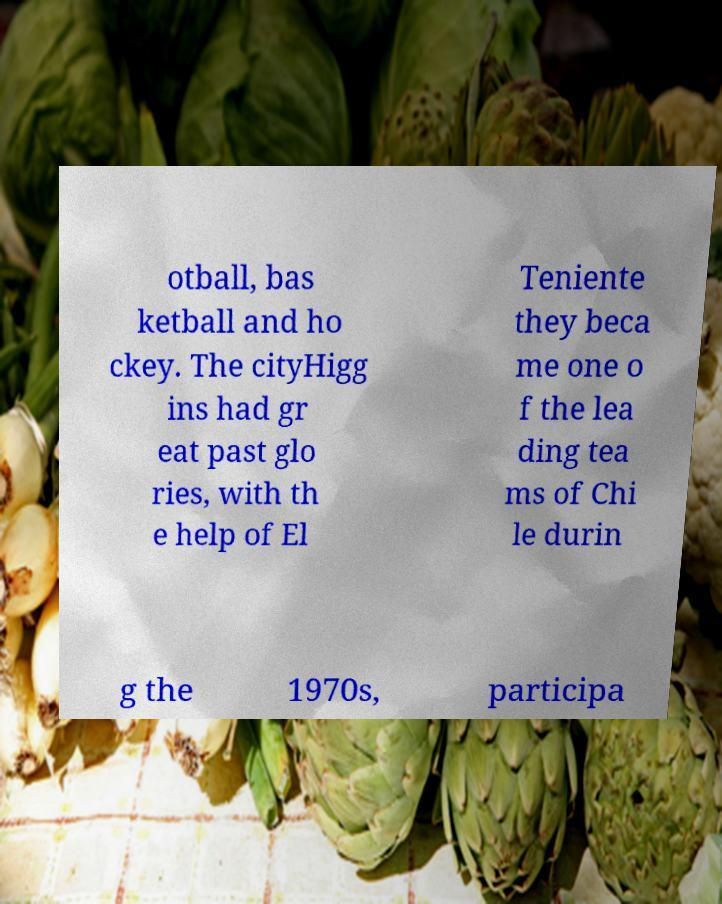Please identify and transcribe the text found in this image. otball, bas ketball and ho ckey. The cityHigg ins had gr eat past glo ries, with th e help of El Teniente they beca me one o f the lea ding tea ms of Chi le durin g the 1970s, participa 